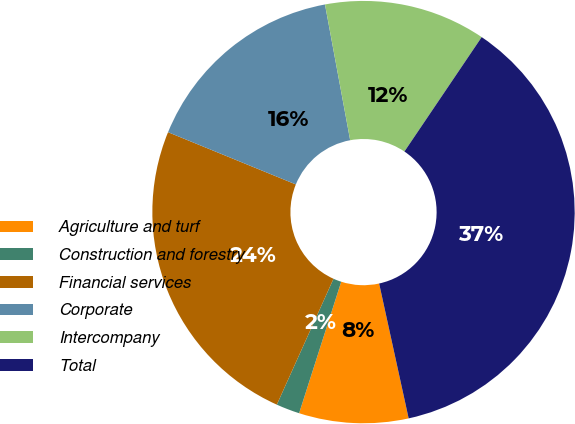Convert chart to OTSL. <chart><loc_0><loc_0><loc_500><loc_500><pie_chart><fcel>Agriculture and turf<fcel>Construction and forestry<fcel>Financial services<fcel>Corporate<fcel>Intercompany<fcel>Total<nl><fcel>8.36%<fcel>1.8%<fcel>24.44%<fcel>15.9%<fcel>12.37%<fcel>37.11%<nl></chart> 